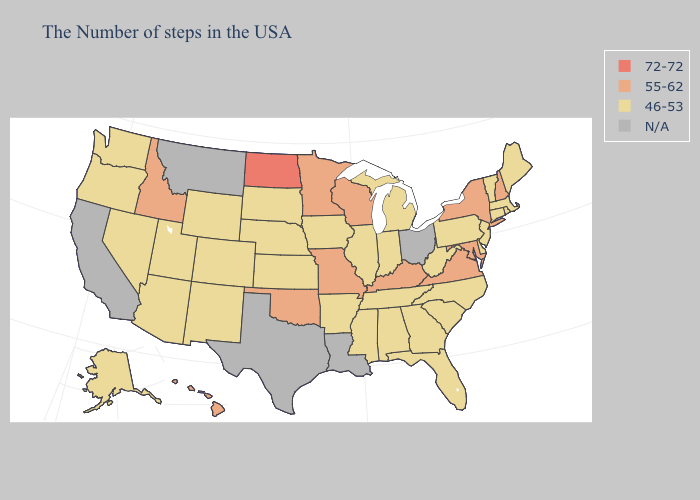Name the states that have a value in the range 55-62?
Write a very short answer. New Hampshire, New York, Maryland, Virginia, Kentucky, Wisconsin, Missouri, Minnesota, Oklahoma, Idaho, Hawaii. Does the map have missing data?
Short answer required. Yes. Does North Dakota have the lowest value in the USA?
Concise answer only. No. Among the states that border Iowa , does South Dakota have the lowest value?
Quick response, please. Yes. Name the states that have a value in the range 55-62?
Be succinct. New Hampshire, New York, Maryland, Virginia, Kentucky, Wisconsin, Missouri, Minnesota, Oklahoma, Idaho, Hawaii. What is the value of Arizona?
Keep it brief. 46-53. Which states have the lowest value in the USA?
Write a very short answer. Maine, Massachusetts, Rhode Island, Vermont, Connecticut, New Jersey, Delaware, Pennsylvania, North Carolina, South Carolina, West Virginia, Florida, Georgia, Michigan, Indiana, Alabama, Tennessee, Illinois, Mississippi, Arkansas, Iowa, Kansas, Nebraska, South Dakota, Wyoming, Colorado, New Mexico, Utah, Arizona, Nevada, Washington, Oregon, Alaska. Among the states that border Rhode Island , which have the highest value?
Keep it brief. Massachusetts, Connecticut. What is the value of Oregon?
Short answer required. 46-53. Name the states that have a value in the range 72-72?
Give a very brief answer. North Dakota. What is the value of Arizona?
Keep it brief. 46-53. Does New York have the highest value in the Northeast?
Give a very brief answer. Yes. What is the value of Massachusetts?
Concise answer only. 46-53. 